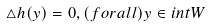Convert formula to latex. <formula><loc_0><loc_0><loc_500><loc_500>\triangle h ( y ) = 0 , ( f o r a l l ) y \in i n t W</formula> 